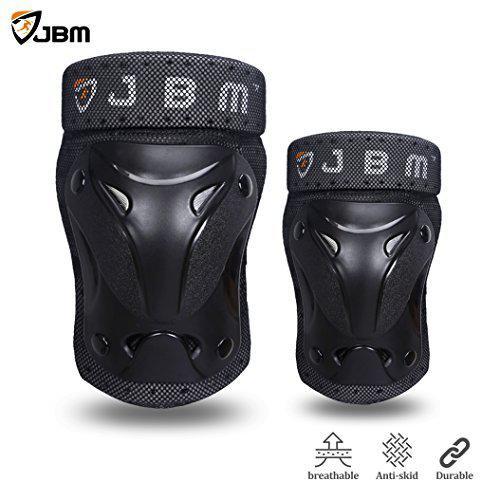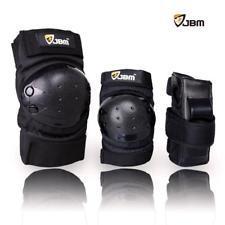The first image is the image on the left, the second image is the image on the right. Examine the images to the left and right. Is the description "There are no more than five knee braces." accurate? Answer yes or no. Yes. The first image is the image on the left, the second image is the image on the right. Evaluate the accuracy of this statement regarding the images: "An image shows a line of three protective gear items, featuring round perforated pads for the knee and elbow.". Is it true? Answer yes or no. Yes. 